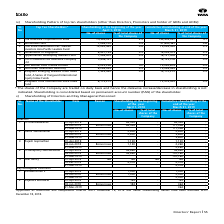According to Tata Consultancy Services's financial document, What information does the table provide? Shareholding pattern of top ten shareholders. The document states: "iv) Shareholding Pattern of top ten shareholders (other than Directors, Promoters and holder of GDRs and ADRs):..." Also, Why are datewise changes in shareholding not indicated? shares of the Company are traded on daily basis. The document states: "* The shares of the Company are traded on daily basis and hence the datewise increase/decrease in shareholding is not indicated. Shareholding is conso..." Also, On what basis is shareholding consolidated? based on permanent account number (PAN) of the shareholder.. The document states: "ing is not indicated. Shareholding is consolidated based on permanent account number (PAN) of the shareholder...." Also, can you calculate: For Life Insurance Corporation of India, what is the change in the number of shares between 2018 and 2019? Based on the calculation: 152,493,927-75,384,947, the result is 77108980. This is based on the information: "1. Life Insurance Corporation of India 75,384,947 3.9 152,493,927 4.1 2. SBI Mutual Fund 7,056,720 0.4 21,680,561 0.6 3. First State Investments Icvc ife Insurance Corporation of India 75,384,947 3.9 ..." The key data points involved are: 152,493,927, 75,384,947. Additionally, In 2018, which shareholder has the highest number of shares? Life Insurance Corporation of India. The document states: "1. Life Insurance Corporation of India 75,384,947 3.9 152,493,927 4.1 2. SBI Mutual Fund 7,056,720 0.4 21,680,561 0.6 3. First State Inves..." Also, can you calculate: For SBI Mutual Fund, what is the change in the number of shares between 2018 and 2019? Based on the calculation: 21,680,561-7,056,720, the result is 14623841. This is based on the information: "75,384,947 3.9 152,493,927 4.1 2. SBI Mutual Fund 7,056,720 0.4 21,680,561 0.6 3. First State Investments Icvc- Stewart Investors Asia Pacific Leaders Fund 15, 152,493,927 4.1 2. SBI Mutual Fund 7,056..." The key data points involved are: 21,680,561, 7,056,720. 